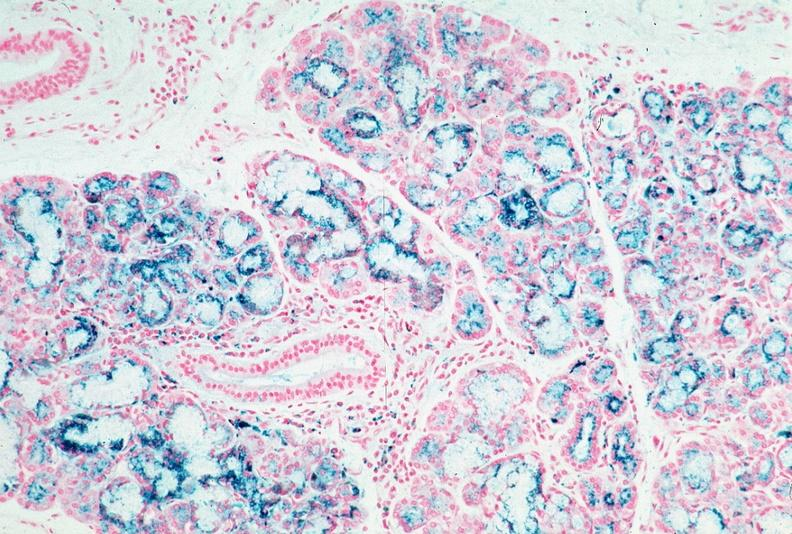does bone, skull show pancreas, hemochromatosis, prussian blue?
Answer the question using a single word or phrase. No 